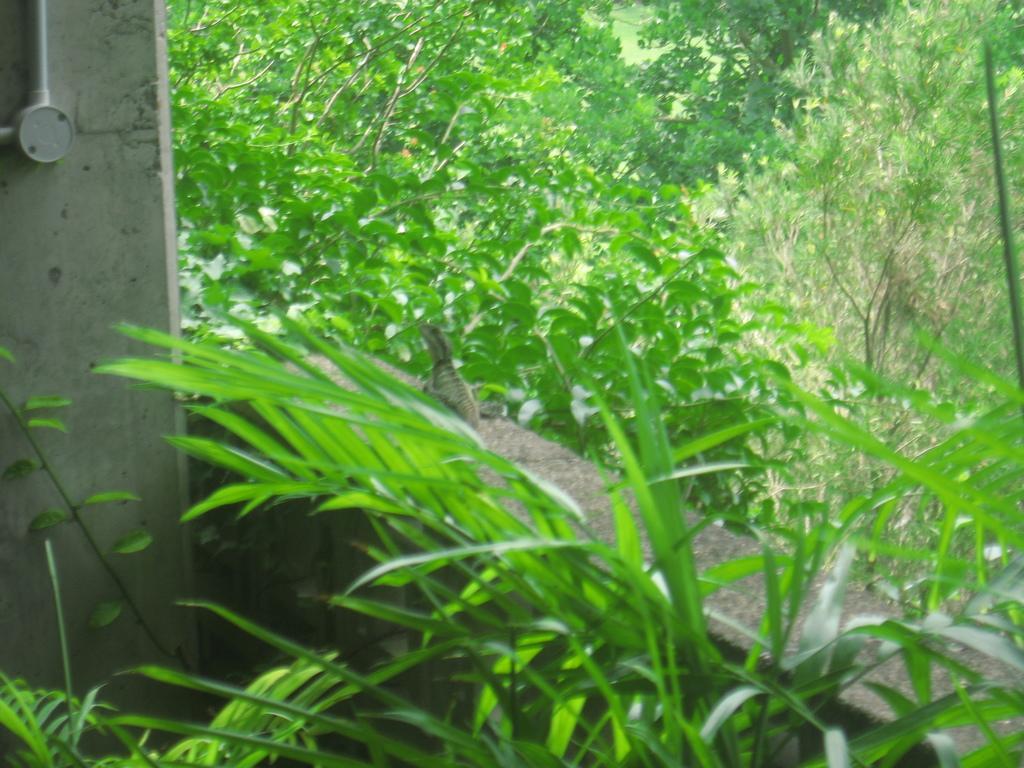In one or two sentences, can you explain what this image depicts? In the picture we can see some plants near the wall and beside it we can see a pillar and on the wall we can see a garden lizard and behind the wall we can see plants and trees. 